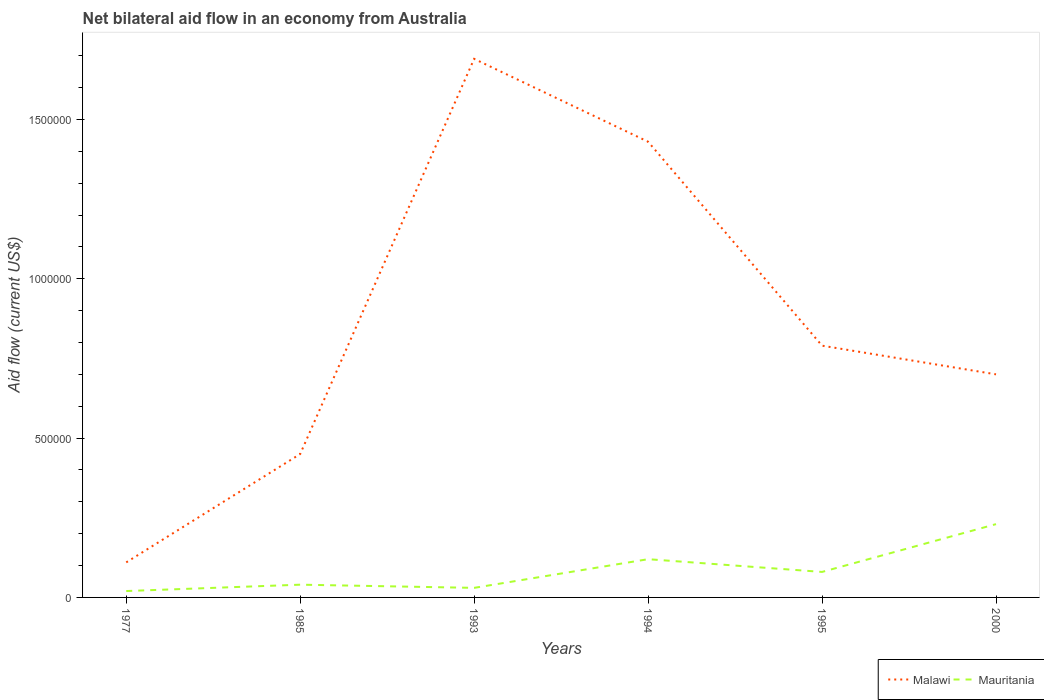How many different coloured lines are there?
Ensure brevity in your answer.  2. Does the line corresponding to Mauritania intersect with the line corresponding to Malawi?
Provide a short and direct response. No. In which year was the net bilateral aid flow in Malawi maximum?
Provide a short and direct response. 1977. What is the difference between the highest and the second highest net bilateral aid flow in Mauritania?
Your response must be concise. 2.10e+05. Is the net bilateral aid flow in Mauritania strictly greater than the net bilateral aid flow in Malawi over the years?
Your answer should be very brief. Yes. How many lines are there?
Ensure brevity in your answer.  2. Does the graph contain grids?
Ensure brevity in your answer.  No. How are the legend labels stacked?
Your answer should be very brief. Horizontal. What is the title of the graph?
Provide a succinct answer. Net bilateral aid flow in an economy from Australia. What is the label or title of the Y-axis?
Provide a succinct answer. Aid flow (current US$). What is the Aid flow (current US$) in Mauritania in 1985?
Provide a succinct answer. 4.00e+04. What is the Aid flow (current US$) of Malawi in 1993?
Offer a terse response. 1.69e+06. What is the Aid flow (current US$) in Malawi in 1994?
Provide a short and direct response. 1.43e+06. What is the Aid flow (current US$) in Malawi in 1995?
Make the answer very short. 7.90e+05. Across all years, what is the maximum Aid flow (current US$) of Malawi?
Keep it short and to the point. 1.69e+06. What is the total Aid flow (current US$) of Malawi in the graph?
Give a very brief answer. 5.17e+06. What is the total Aid flow (current US$) of Mauritania in the graph?
Your answer should be compact. 5.20e+05. What is the difference between the Aid flow (current US$) in Malawi in 1977 and that in 1985?
Provide a succinct answer. -3.40e+05. What is the difference between the Aid flow (current US$) of Malawi in 1977 and that in 1993?
Offer a terse response. -1.58e+06. What is the difference between the Aid flow (current US$) of Mauritania in 1977 and that in 1993?
Your answer should be very brief. -10000. What is the difference between the Aid flow (current US$) of Malawi in 1977 and that in 1994?
Give a very brief answer. -1.32e+06. What is the difference between the Aid flow (current US$) in Malawi in 1977 and that in 1995?
Offer a terse response. -6.80e+05. What is the difference between the Aid flow (current US$) in Malawi in 1977 and that in 2000?
Offer a terse response. -5.90e+05. What is the difference between the Aid flow (current US$) of Mauritania in 1977 and that in 2000?
Your answer should be very brief. -2.10e+05. What is the difference between the Aid flow (current US$) of Malawi in 1985 and that in 1993?
Your answer should be very brief. -1.24e+06. What is the difference between the Aid flow (current US$) of Mauritania in 1985 and that in 1993?
Make the answer very short. 10000. What is the difference between the Aid flow (current US$) in Malawi in 1985 and that in 1994?
Provide a short and direct response. -9.80e+05. What is the difference between the Aid flow (current US$) of Mauritania in 1985 and that in 1994?
Offer a very short reply. -8.00e+04. What is the difference between the Aid flow (current US$) in Mauritania in 1985 and that in 1995?
Provide a succinct answer. -4.00e+04. What is the difference between the Aid flow (current US$) in Mauritania in 1985 and that in 2000?
Provide a succinct answer. -1.90e+05. What is the difference between the Aid flow (current US$) in Malawi in 1993 and that in 1995?
Provide a short and direct response. 9.00e+05. What is the difference between the Aid flow (current US$) of Malawi in 1993 and that in 2000?
Provide a succinct answer. 9.90e+05. What is the difference between the Aid flow (current US$) of Mauritania in 1993 and that in 2000?
Ensure brevity in your answer.  -2.00e+05. What is the difference between the Aid flow (current US$) of Malawi in 1994 and that in 1995?
Your response must be concise. 6.40e+05. What is the difference between the Aid flow (current US$) of Malawi in 1994 and that in 2000?
Offer a terse response. 7.30e+05. What is the difference between the Aid flow (current US$) of Mauritania in 1994 and that in 2000?
Ensure brevity in your answer.  -1.10e+05. What is the difference between the Aid flow (current US$) of Mauritania in 1995 and that in 2000?
Your response must be concise. -1.50e+05. What is the difference between the Aid flow (current US$) of Malawi in 1977 and the Aid flow (current US$) of Mauritania in 1985?
Make the answer very short. 7.00e+04. What is the difference between the Aid flow (current US$) in Malawi in 1977 and the Aid flow (current US$) in Mauritania in 1995?
Make the answer very short. 3.00e+04. What is the difference between the Aid flow (current US$) in Malawi in 1977 and the Aid flow (current US$) in Mauritania in 2000?
Ensure brevity in your answer.  -1.20e+05. What is the difference between the Aid flow (current US$) of Malawi in 1985 and the Aid flow (current US$) of Mauritania in 1994?
Your answer should be very brief. 3.30e+05. What is the difference between the Aid flow (current US$) of Malawi in 1985 and the Aid flow (current US$) of Mauritania in 1995?
Your answer should be very brief. 3.70e+05. What is the difference between the Aid flow (current US$) in Malawi in 1985 and the Aid flow (current US$) in Mauritania in 2000?
Offer a very short reply. 2.20e+05. What is the difference between the Aid flow (current US$) in Malawi in 1993 and the Aid flow (current US$) in Mauritania in 1994?
Keep it short and to the point. 1.57e+06. What is the difference between the Aid flow (current US$) of Malawi in 1993 and the Aid flow (current US$) of Mauritania in 1995?
Provide a succinct answer. 1.61e+06. What is the difference between the Aid flow (current US$) of Malawi in 1993 and the Aid flow (current US$) of Mauritania in 2000?
Ensure brevity in your answer.  1.46e+06. What is the difference between the Aid flow (current US$) of Malawi in 1994 and the Aid flow (current US$) of Mauritania in 1995?
Offer a terse response. 1.35e+06. What is the difference between the Aid flow (current US$) of Malawi in 1994 and the Aid flow (current US$) of Mauritania in 2000?
Make the answer very short. 1.20e+06. What is the difference between the Aid flow (current US$) in Malawi in 1995 and the Aid flow (current US$) in Mauritania in 2000?
Make the answer very short. 5.60e+05. What is the average Aid flow (current US$) of Malawi per year?
Your answer should be very brief. 8.62e+05. What is the average Aid flow (current US$) of Mauritania per year?
Keep it short and to the point. 8.67e+04. In the year 1977, what is the difference between the Aid flow (current US$) of Malawi and Aid flow (current US$) of Mauritania?
Keep it short and to the point. 9.00e+04. In the year 1985, what is the difference between the Aid flow (current US$) in Malawi and Aid flow (current US$) in Mauritania?
Your answer should be very brief. 4.10e+05. In the year 1993, what is the difference between the Aid flow (current US$) in Malawi and Aid flow (current US$) in Mauritania?
Provide a succinct answer. 1.66e+06. In the year 1994, what is the difference between the Aid flow (current US$) of Malawi and Aid flow (current US$) of Mauritania?
Your answer should be very brief. 1.31e+06. In the year 1995, what is the difference between the Aid flow (current US$) in Malawi and Aid flow (current US$) in Mauritania?
Offer a terse response. 7.10e+05. What is the ratio of the Aid flow (current US$) in Malawi in 1977 to that in 1985?
Offer a terse response. 0.24. What is the ratio of the Aid flow (current US$) of Malawi in 1977 to that in 1993?
Make the answer very short. 0.07. What is the ratio of the Aid flow (current US$) of Mauritania in 1977 to that in 1993?
Ensure brevity in your answer.  0.67. What is the ratio of the Aid flow (current US$) of Malawi in 1977 to that in 1994?
Provide a succinct answer. 0.08. What is the ratio of the Aid flow (current US$) of Malawi in 1977 to that in 1995?
Ensure brevity in your answer.  0.14. What is the ratio of the Aid flow (current US$) of Mauritania in 1977 to that in 1995?
Keep it short and to the point. 0.25. What is the ratio of the Aid flow (current US$) of Malawi in 1977 to that in 2000?
Offer a terse response. 0.16. What is the ratio of the Aid flow (current US$) in Mauritania in 1977 to that in 2000?
Offer a terse response. 0.09. What is the ratio of the Aid flow (current US$) in Malawi in 1985 to that in 1993?
Ensure brevity in your answer.  0.27. What is the ratio of the Aid flow (current US$) in Malawi in 1985 to that in 1994?
Provide a short and direct response. 0.31. What is the ratio of the Aid flow (current US$) of Malawi in 1985 to that in 1995?
Provide a succinct answer. 0.57. What is the ratio of the Aid flow (current US$) of Mauritania in 1985 to that in 1995?
Make the answer very short. 0.5. What is the ratio of the Aid flow (current US$) of Malawi in 1985 to that in 2000?
Ensure brevity in your answer.  0.64. What is the ratio of the Aid flow (current US$) in Mauritania in 1985 to that in 2000?
Give a very brief answer. 0.17. What is the ratio of the Aid flow (current US$) in Malawi in 1993 to that in 1994?
Make the answer very short. 1.18. What is the ratio of the Aid flow (current US$) in Mauritania in 1993 to that in 1994?
Your answer should be compact. 0.25. What is the ratio of the Aid flow (current US$) of Malawi in 1993 to that in 1995?
Your answer should be compact. 2.14. What is the ratio of the Aid flow (current US$) in Malawi in 1993 to that in 2000?
Ensure brevity in your answer.  2.41. What is the ratio of the Aid flow (current US$) in Mauritania in 1993 to that in 2000?
Ensure brevity in your answer.  0.13. What is the ratio of the Aid flow (current US$) in Malawi in 1994 to that in 1995?
Your response must be concise. 1.81. What is the ratio of the Aid flow (current US$) in Mauritania in 1994 to that in 1995?
Ensure brevity in your answer.  1.5. What is the ratio of the Aid flow (current US$) of Malawi in 1994 to that in 2000?
Make the answer very short. 2.04. What is the ratio of the Aid flow (current US$) of Mauritania in 1994 to that in 2000?
Ensure brevity in your answer.  0.52. What is the ratio of the Aid flow (current US$) of Malawi in 1995 to that in 2000?
Offer a very short reply. 1.13. What is the ratio of the Aid flow (current US$) in Mauritania in 1995 to that in 2000?
Make the answer very short. 0.35. What is the difference between the highest and the second highest Aid flow (current US$) in Mauritania?
Your response must be concise. 1.10e+05. What is the difference between the highest and the lowest Aid flow (current US$) in Malawi?
Give a very brief answer. 1.58e+06. 